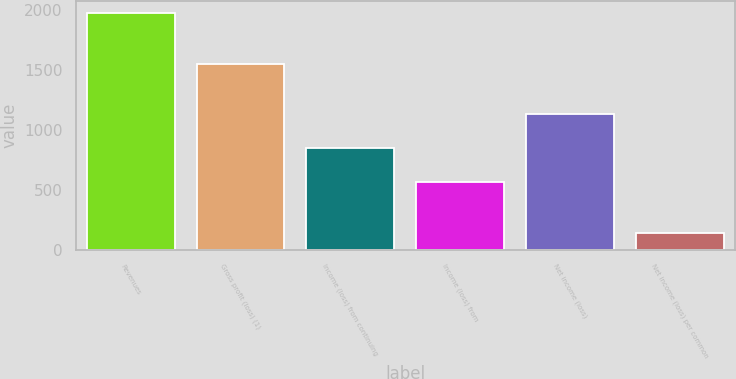Convert chart. <chart><loc_0><loc_0><loc_500><loc_500><bar_chart><fcel>Revenues<fcel>Gross profit (loss) (1)<fcel>Income (loss) from continuing<fcel>Income (loss) from<fcel>Net income (loss)<fcel>Net income (loss) per common<nl><fcel>1973.96<fcel>1550.99<fcel>846.04<fcel>564.06<fcel>1128.02<fcel>141.09<nl></chart> 